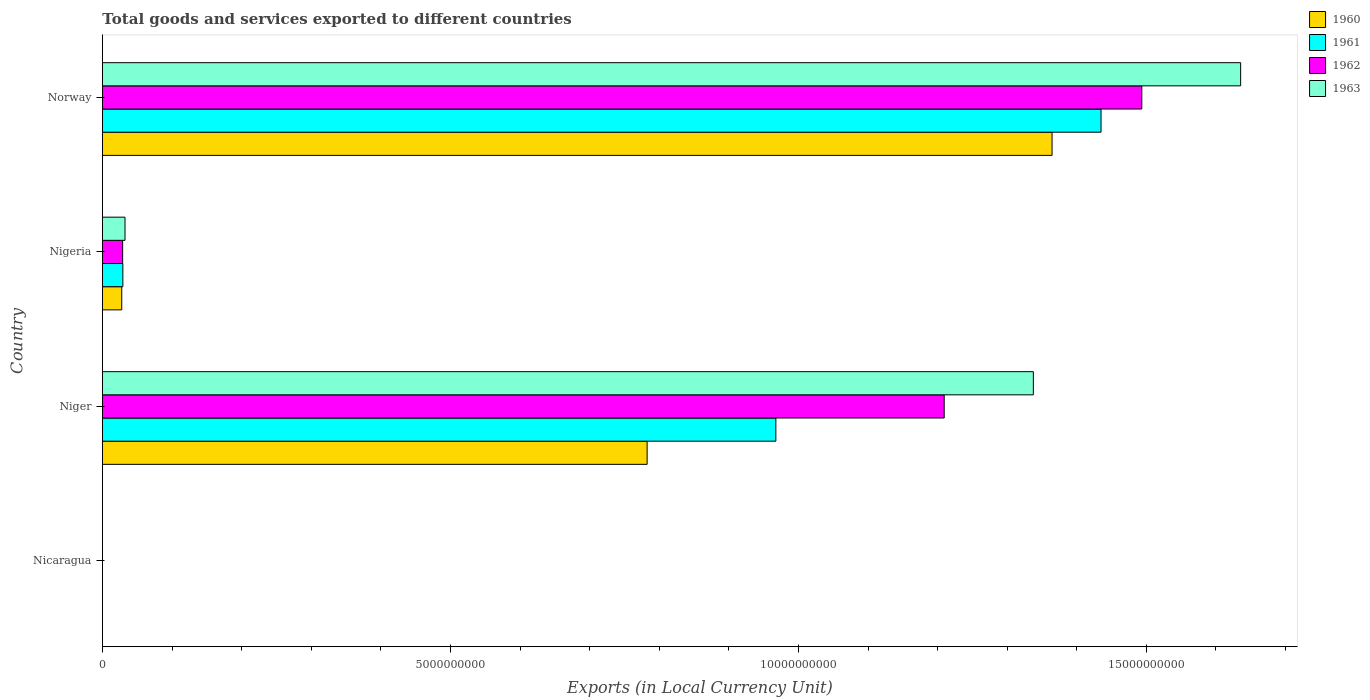How many different coloured bars are there?
Your response must be concise. 4. Are the number of bars per tick equal to the number of legend labels?
Your response must be concise. Yes. Are the number of bars on each tick of the Y-axis equal?
Ensure brevity in your answer.  Yes. How many bars are there on the 1st tick from the top?
Your answer should be very brief. 4. What is the label of the 3rd group of bars from the top?
Provide a short and direct response. Niger. In how many cases, is the number of bars for a given country not equal to the number of legend labels?
Offer a very short reply. 0. What is the Amount of goods and services exports in 1963 in Niger?
Provide a succinct answer. 1.34e+1. Across all countries, what is the maximum Amount of goods and services exports in 1960?
Your response must be concise. 1.36e+1. Across all countries, what is the minimum Amount of goods and services exports in 1961?
Make the answer very short. 0.12. In which country was the Amount of goods and services exports in 1962 maximum?
Your answer should be very brief. Norway. In which country was the Amount of goods and services exports in 1960 minimum?
Your response must be concise. Nicaragua. What is the total Amount of goods and services exports in 1962 in the graph?
Your answer should be compact. 2.73e+1. What is the difference between the Amount of goods and services exports in 1961 in Nicaragua and that in Niger?
Your answer should be compact. -9.68e+09. What is the difference between the Amount of goods and services exports in 1960 in Nicaragua and the Amount of goods and services exports in 1961 in Norway?
Offer a very short reply. -1.43e+1. What is the average Amount of goods and services exports in 1963 per country?
Your answer should be very brief. 7.51e+09. What is the difference between the Amount of goods and services exports in 1961 and Amount of goods and services exports in 1963 in Nicaragua?
Your answer should be compact. -0.06. What is the ratio of the Amount of goods and services exports in 1960 in Niger to that in Nigeria?
Ensure brevity in your answer.  28.25. What is the difference between the highest and the second highest Amount of goods and services exports in 1962?
Keep it short and to the point. 2.84e+09. What is the difference between the highest and the lowest Amount of goods and services exports in 1962?
Your answer should be very brief. 1.49e+1. Is it the case that in every country, the sum of the Amount of goods and services exports in 1961 and Amount of goods and services exports in 1960 is greater than the sum of Amount of goods and services exports in 1963 and Amount of goods and services exports in 1962?
Offer a terse response. No. Is it the case that in every country, the sum of the Amount of goods and services exports in 1962 and Amount of goods and services exports in 1961 is greater than the Amount of goods and services exports in 1963?
Your answer should be very brief. Yes. How many bars are there?
Your response must be concise. 16. Are the values on the major ticks of X-axis written in scientific E-notation?
Your response must be concise. No. How are the legend labels stacked?
Make the answer very short. Vertical. What is the title of the graph?
Ensure brevity in your answer.  Total goods and services exported to different countries. What is the label or title of the X-axis?
Offer a terse response. Exports (in Local Currency Unit). What is the Exports (in Local Currency Unit) in 1960 in Nicaragua?
Make the answer very short. 0.11. What is the Exports (in Local Currency Unit) of 1961 in Nicaragua?
Your answer should be compact. 0.12. What is the Exports (in Local Currency Unit) of 1962 in Nicaragua?
Your response must be concise. 0.15. What is the Exports (in Local Currency Unit) in 1963 in Nicaragua?
Provide a succinct answer. 0.18. What is the Exports (in Local Currency Unit) in 1960 in Niger?
Provide a short and direct response. 7.83e+09. What is the Exports (in Local Currency Unit) of 1961 in Niger?
Make the answer very short. 9.68e+09. What is the Exports (in Local Currency Unit) of 1962 in Niger?
Offer a very short reply. 1.21e+1. What is the Exports (in Local Currency Unit) of 1963 in Niger?
Make the answer very short. 1.34e+1. What is the Exports (in Local Currency Unit) of 1960 in Nigeria?
Keep it short and to the point. 2.77e+08. What is the Exports (in Local Currency Unit) of 1961 in Nigeria?
Offer a very short reply. 2.93e+08. What is the Exports (in Local Currency Unit) in 1962 in Nigeria?
Your response must be concise. 2.90e+08. What is the Exports (in Local Currency Unit) of 1963 in Nigeria?
Your answer should be very brief. 3.24e+08. What is the Exports (in Local Currency Unit) of 1960 in Norway?
Offer a very short reply. 1.36e+1. What is the Exports (in Local Currency Unit) of 1961 in Norway?
Keep it short and to the point. 1.43e+1. What is the Exports (in Local Currency Unit) in 1962 in Norway?
Give a very brief answer. 1.49e+1. What is the Exports (in Local Currency Unit) of 1963 in Norway?
Your answer should be compact. 1.64e+1. Across all countries, what is the maximum Exports (in Local Currency Unit) of 1960?
Offer a very short reply. 1.36e+1. Across all countries, what is the maximum Exports (in Local Currency Unit) in 1961?
Your answer should be compact. 1.43e+1. Across all countries, what is the maximum Exports (in Local Currency Unit) in 1962?
Make the answer very short. 1.49e+1. Across all countries, what is the maximum Exports (in Local Currency Unit) of 1963?
Your answer should be very brief. 1.64e+1. Across all countries, what is the minimum Exports (in Local Currency Unit) of 1960?
Make the answer very short. 0.11. Across all countries, what is the minimum Exports (in Local Currency Unit) in 1961?
Offer a very short reply. 0.12. Across all countries, what is the minimum Exports (in Local Currency Unit) in 1962?
Your response must be concise. 0.15. Across all countries, what is the minimum Exports (in Local Currency Unit) in 1963?
Your answer should be compact. 0.18. What is the total Exports (in Local Currency Unit) of 1960 in the graph?
Your answer should be compact. 2.17e+1. What is the total Exports (in Local Currency Unit) in 1961 in the graph?
Keep it short and to the point. 2.43e+1. What is the total Exports (in Local Currency Unit) of 1962 in the graph?
Give a very brief answer. 2.73e+1. What is the total Exports (in Local Currency Unit) in 1963 in the graph?
Ensure brevity in your answer.  3.01e+1. What is the difference between the Exports (in Local Currency Unit) in 1960 in Nicaragua and that in Niger?
Offer a terse response. -7.83e+09. What is the difference between the Exports (in Local Currency Unit) in 1961 in Nicaragua and that in Niger?
Your response must be concise. -9.68e+09. What is the difference between the Exports (in Local Currency Unit) of 1962 in Nicaragua and that in Niger?
Offer a very short reply. -1.21e+1. What is the difference between the Exports (in Local Currency Unit) of 1963 in Nicaragua and that in Niger?
Provide a succinct answer. -1.34e+1. What is the difference between the Exports (in Local Currency Unit) of 1960 in Nicaragua and that in Nigeria?
Your answer should be compact. -2.77e+08. What is the difference between the Exports (in Local Currency Unit) of 1961 in Nicaragua and that in Nigeria?
Offer a very short reply. -2.93e+08. What is the difference between the Exports (in Local Currency Unit) in 1962 in Nicaragua and that in Nigeria?
Give a very brief answer. -2.90e+08. What is the difference between the Exports (in Local Currency Unit) in 1963 in Nicaragua and that in Nigeria?
Make the answer very short. -3.24e+08. What is the difference between the Exports (in Local Currency Unit) of 1960 in Nicaragua and that in Norway?
Provide a succinct answer. -1.36e+1. What is the difference between the Exports (in Local Currency Unit) in 1961 in Nicaragua and that in Norway?
Give a very brief answer. -1.43e+1. What is the difference between the Exports (in Local Currency Unit) of 1962 in Nicaragua and that in Norway?
Ensure brevity in your answer.  -1.49e+1. What is the difference between the Exports (in Local Currency Unit) of 1963 in Nicaragua and that in Norway?
Offer a very short reply. -1.64e+1. What is the difference between the Exports (in Local Currency Unit) in 1960 in Niger and that in Nigeria?
Your answer should be very brief. 7.55e+09. What is the difference between the Exports (in Local Currency Unit) in 1961 in Niger and that in Nigeria?
Your response must be concise. 9.38e+09. What is the difference between the Exports (in Local Currency Unit) in 1962 in Niger and that in Nigeria?
Provide a succinct answer. 1.18e+1. What is the difference between the Exports (in Local Currency Unit) in 1963 in Niger and that in Nigeria?
Keep it short and to the point. 1.31e+1. What is the difference between the Exports (in Local Currency Unit) in 1960 in Niger and that in Norway?
Offer a very short reply. -5.82e+09. What is the difference between the Exports (in Local Currency Unit) in 1961 in Niger and that in Norway?
Keep it short and to the point. -4.67e+09. What is the difference between the Exports (in Local Currency Unit) in 1962 in Niger and that in Norway?
Your response must be concise. -2.84e+09. What is the difference between the Exports (in Local Currency Unit) in 1963 in Niger and that in Norway?
Offer a terse response. -2.98e+09. What is the difference between the Exports (in Local Currency Unit) in 1960 in Nigeria and that in Norway?
Offer a very short reply. -1.34e+1. What is the difference between the Exports (in Local Currency Unit) of 1961 in Nigeria and that in Norway?
Ensure brevity in your answer.  -1.41e+1. What is the difference between the Exports (in Local Currency Unit) of 1962 in Nigeria and that in Norway?
Your answer should be very brief. -1.46e+1. What is the difference between the Exports (in Local Currency Unit) in 1963 in Nigeria and that in Norway?
Provide a succinct answer. -1.60e+1. What is the difference between the Exports (in Local Currency Unit) in 1960 in Nicaragua and the Exports (in Local Currency Unit) in 1961 in Niger?
Ensure brevity in your answer.  -9.68e+09. What is the difference between the Exports (in Local Currency Unit) in 1960 in Nicaragua and the Exports (in Local Currency Unit) in 1962 in Niger?
Offer a very short reply. -1.21e+1. What is the difference between the Exports (in Local Currency Unit) of 1960 in Nicaragua and the Exports (in Local Currency Unit) of 1963 in Niger?
Provide a short and direct response. -1.34e+1. What is the difference between the Exports (in Local Currency Unit) of 1961 in Nicaragua and the Exports (in Local Currency Unit) of 1962 in Niger?
Your answer should be compact. -1.21e+1. What is the difference between the Exports (in Local Currency Unit) in 1961 in Nicaragua and the Exports (in Local Currency Unit) in 1963 in Niger?
Offer a very short reply. -1.34e+1. What is the difference between the Exports (in Local Currency Unit) of 1962 in Nicaragua and the Exports (in Local Currency Unit) of 1963 in Niger?
Offer a terse response. -1.34e+1. What is the difference between the Exports (in Local Currency Unit) of 1960 in Nicaragua and the Exports (in Local Currency Unit) of 1961 in Nigeria?
Ensure brevity in your answer.  -2.93e+08. What is the difference between the Exports (in Local Currency Unit) in 1960 in Nicaragua and the Exports (in Local Currency Unit) in 1962 in Nigeria?
Offer a terse response. -2.90e+08. What is the difference between the Exports (in Local Currency Unit) of 1960 in Nicaragua and the Exports (in Local Currency Unit) of 1963 in Nigeria?
Make the answer very short. -3.24e+08. What is the difference between the Exports (in Local Currency Unit) in 1961 in Nicaragua and the Exports (in Local Currency Unit) in 1962 in Nigeria?
Give a very brief answer. -2.90e+08. What is the difference between the Exports (in Local Currency Unit) in 1961 in Nicaragua and the Exports (in Local Currency Unit) in 1963 in Nigeria?
Offer a terse response. -3.24e+08. What is the difference between the Exports (in Local Currency Unit) in 1962 in Nicaragua and the Exports (in Local Currency Unit) in 1963 in Nigeria?
Provide a short and direct response. -3.24e+08. What is the difference between the Exports (in Local Currency Unit) of 1960 in Nicaragua and the Exports (in Local Currency Unit) of 1961 in Norway?
Your answer should be very brief. -1.43e+1. What is the difference between the Exports (in Local Currency Unit) of 1960 in Nicaragua and the Exports (in Local Currency Unit) of 1962 in Norway?
Your answer should be very brief. -1.49e+1. What is the difference between the Exports (in Local Currency Unit) in 1960 in Nicaragua and the Exports (in Local Currency Unit) in 1963 in Norway?
Keep it short and to the point. -1.64e+1. What is the difference between the Exports (in Local Currency Unit) of 1961 in Nicaragua and the Exports (in Local Currency Unit) of 1962 in Norway?
Offer a very short reply. -1.49e+1. What is the difference between the Exports (in Local Currency Unit) in 1961 in Nicaragua and the Exports (in Local Currency Unit) in 1963 in Norway?
Your answer should be compact. -1.64e+1. What is the difference between the Exports (in Local Currency Unit) of 1962 in Nicaragua and the Exports (in Local Currency Unit) of 1963 in Norway?
Keep it short and to the point. -1.64e+1. What is the difference between the Exports (in Local Currency Unit) of 1960 in Niger and the Exports (in Local Currency Unit) of 1961 in Nigeria?
Keep it short and to the point. 7.53e+09. What is the difference between the Exports (in Local Currency Unit) of 1960 in Niger and the Exports (in Local Currency Unit) of 1962 in Nigeria?
Provide a short and direct response. 7.54e+09. What is the difference between the Exports (in Local Currency Unit) of 1960 in Niger and the Exports (in Local Currency Unit) of 1963 in Nigeria?
Keep it short and to the point. 7.50e+09. What is the difference between the Exports (in Local Currency Unit) of 1961 in Niger and the Exports (in Local Currency Unit) of 1962 in Nigeria?
Ensure brevity in your answer.  9.39e+09. What is the difference between the Exports (in Local Currency Unit) in 1961 in Niger and the Exports (in Local Currency Unit) in 1963 in Nigeria?
Give a very brief answer. 9.35e+09. What is the difference between the Exports (in Local Currency Unit) of 1962 in Niger and the Exports (in Local Currency Unit) of 1963 in Nigeria?
Ensure brevity in your answer.  1.18e+1. What is the difference between the Exports (in Local Currency Unit) in 1960 in Niger and the Exports (in Local Currency Unit) in 1961 in Norway?
Your answer should be very brief. -6.52e+09. What is the difference between the Exports (in Local Currency Unit) of 1960 in Niger and the Exports (in Local Currency Unit) of 1962 in Norway?
Give a very brief answer. -7.11e+09. What is the difference between the Exports (in Local Currency Unit) of 1960 in Niger and the Exports (in Local Currency Unit) of 1963 in Norway?
Your answer should be compact. -8.53e+09. What is the difference between the Exports (in Local Currency Unit) in 1961 in Niger and the Exports (in Local Currency Unit) in 1962 in Norway?
Provide a succinct answer. -5.26e+09. What is the difference between the Exports (in Local Currency Unit) in 1961 in Niger and the Exports (in Local Currency Unit) in 1963 in Norway?
Make the answer very short. -6.68e+09. What is the difference between the Exports (in Local Currency Unit) of 1962 in Niger and the Exports (in Local Currency Unit) of 1963 in Norway?
Provide a succinct answer. -4.26e+09. What is the difference between the Exports (in Local Currency Unit) of 1960 in Nigeria and the Exports (in Local Currency Unit) of 1961 in Norway?
Your response must be concise. -1.41e+1. What is the difference between the Exports (in Local Currency Unit) of 1960 in Nigeria and the Exports (in Local Currency Unit) of 1962 in Norway?
Offer a terse response. -1.47e+1. What is the difference between the Exports (in Local Currency Unit) of 1960 in Nigeria and the Exports (in Local Currency Unit) of 1963 in Norway?
Your response must be concise. -1.61e+1. What is the difference between the Exports (in Local Currency Unit) of 1961 in Nigeria and the Exports (in Local Currency Unit) of 1962 in Norway?
Make the answer very short. -1.46e+1. What is the difference between the Exports (in Local Currency Unit) in 1961 in Nigeria and the Exports (in Local Currency Unit) in 1963 in Norway?
Your response must be concise. -1.61e+1. What is the difference between the Exports (in Local Currency Unit) in 1962 in Nigeria and the Exports (in Local Currency Unit) in 1963 in Norway?
Give a very brief answer. -1.61e+1. What is the average Exports (in Local Currency Unit) in 1960 per country?
Ensure brevity in your answer.  5.44e+09. What is the average Exports (in Local Currency Unit) in 1961 per country?
Offer a very short reply. 6.08e+09. What is the average Exports (in Local Currency Unit) of 1962 per country?
Provide a succinct answer. 6.83e+09. What is the average Exports (in Local Currency Unit) of 1963 per country?
Provide a succinct answer. 7.51e+09. What is the difference between the Exports (in Local Currency Unit) in 1960 and Exports (in Local Currency Unit) in 1961 in Nicaragua?
Your response must be concise. -0.01. What is the difference between the Exports (in Local Currency Unit) in 1960 and Exports (in Local Currency Unit) in 1962 in Nicaragua?
Offer a terse response. -0.04. What is the difference between the Exports (in Local Currency Unit) in 1960 and Exports (in Local Currency Unit) in 1963 in Nicaragua?
Keep it short and to the point. -0.07. What is the difference between the Exports (in Local Currency Unit) of 1961 and Exports (in Local Currency Unit) of 1962 in Nicaragua?
Make the answer very short. -0.03. What is the difference between the Exports (in Local Currency Unit) of 1961 and Exports (in Local Currency Unit) of 1963 in Nicaragua?
Offer a very short reply. -0.06. What is the difference between the Exports (in Local Currency Unit) in 1962 and Exports (in Local Currency Unit) in 1963 in Nicaragua?
Provide a succinct answer. -0.03. What is the difference between the Exports (in Local Currency Unit) in 1960 and Exports (in Local Currency Unit) in 1961 in Niger?
Your answer should be very brief. -1.85e+09. What is the difference between the Exports (in Local Currency Unit) in 1960 and Exports (in Local Currency Unit) in 1962 in Niger?
Ensure brevity in your answer.  -4.27e+09. What is the difference between the Exports (in Local Currency Unit) in 1960 and Exports (in Local Currency Unit) in 1963 in Niger?
Give a very brief answer. -5.55e+09. What is the difference between the Exports (in Local Currency Unit) in 1961 and Exports (in Local Currency Unit) in 1962 in Niger?
Give a very brief answer. -2.42e+09. What is the difference between the Exports (in Local Currency Unit) of 1961 and Exports (in Local Currency Unit) of 1963 in Niger?
Offer a very short reply. -3.70e+09. What is the difference between the Exports (in Local Currency Unit) in 1962 and Exports (in Local Currency Unit) in 1963 in Niger?
Your response must be concise. -1.28e+09. What is the difference between the Exports (in Local Currency Unit) in 1960 and Exports (in Local Currency Unit) in 1961 in Nigeria?
Make the answer very short. -1.61e+07. What is the difference between the Exports (in Local Currency Unit) of 1960 and Exports (in Local Currency Unit) of 1962 in Nigeria?
Provide a short and direct response. -1.30e+07. What is the difference between the Exports (in Local Currency Unit) of 1960 and Exports (in Local Currency Unit) of 1963 in Nigeria?
Provide a succinct answer. -4.69e+07. What is the difference between the Exports (in Local Currency Unit) in 1961 and Exports (in Local Currency Unit) in 1962 in Nigeria?
Your response must be concise. 3.12e+06. What is the difference between the Exports (in Local Currency Unit) of 1961 and Exports (in Local Currency Unit) of 1963 in Nigeria?
Provide a short and direct response. -3.08e+07. What is the difference between the Exports (in Local Currency Unit) of 1962 and Exports (in Local Currency Unit) of 1963 in Nigeria?
Give a very brief answer. -3.40e+07. What is the difference between the Exports (in Local Currency Unit) in 1960 and Exports (in Local Currency Unit) in 1961 in Norway?
Ensure brevity in your answer.  -7.04e+08. What is the difference between the Exports (in Local Currency Unit) in 1960 and Exports (in Local Currency Unit) in 1962 in Norway?
Provide a succinct answer. -1.29e+09. What is the difference between the Exports (in Local Currency Unit) in 1960 and Exports (in Local Currency Unit) in 1963 in Norway?
Keep it short and to the point. -2.71e+09. What is the difference between the Exports (in Local Currency Unit) in 1961 and Exports (in Local Currency Unit) in 1962 in Norway?
Keep it short and to the point. -5.86e+08. What is the difference between the Exports (in Local Currency Unit) of 1961 and Exports (in Local Currency Unit) of 1963 in Norway?
Provide a short and direct response. -2.01e+09. What is the difference between the Exports (in Local Currency Unit) of 1962 and Exports (in Local Currency Unit) of 1963 in Norway?
Ensure brevity in your answer.  -1.42e+09. What is the ratio of the Exports (in Local Currency Unit) of 1960 in Nicaragua to that in Niger?
Keep it short and to the point. 0. What is the ratio of the Exports (in Local Currency Unit) of 1961 in Nicaragua to that in Niger?
Provide a succinct answer. 0. What is the ratio of the Exports (in Local Currency Unit) of 1962 in Nicaragua to that in Niger?
Your response must be concise. 0. What is the ratio of the Exports (in Local Currency Unit) in 1963 in Nicaragua to that in Nigeria?
Provide a succinct answer. 0. What is the ratio of the Exports (in Local Currency Unit) in 1960 in Nicaragua to that in Norway?
Offer a terse response. 0. What is the ratio of the Exports (in Local Currency Unit) of 1961 in Nicaragua to that in Norway?
Give a very brief answer. 0. What is the ratio of the Exports (in Local Currency Unit) in 1962 in Nicaragua to that in Norway?
Make the answer very short. 0. What is the ratio of the Exports (in Local Currency Unit) of 1960 in Niger to that in Nigeria?
Offer a very short reply. 28.25. What is the ratio of the Exports (in Local Currency Unit) in 1961 in Niger to that in Nigeria?
Make the answer very short. 33.01. What is the ratio of the Exports (in Local Currency Unit) of 1962 in Niger to that in Nigeria?
Offer a very short reply. 41.71. What is the ratio of the Exports (in Local Currency Unit) of 1963 in Niger to that in Nigeria?
Your answer should be very brief. 41.29. What is the ratio of the Exports (in Local Currency Unit) in 1960 in Niger to that in Norway?
Give a very brief answer. 0.57. What is the ratio of the Exports (in Local Currency Unit) in 1961 in Niger to that in Norway?
Ensure brevity in your answer.  0.67. What is the ratio of the Exports (in Local Currency Unit) of 1962 in Niger to that in Norway?
Your answer should be very brief. 0.81. What is the ratio of the Exports (in Local Currency Unit) in 1963 in Niger to that in Norway?
Keep it short and to the point. 0.82. What is the ratio of the Exports (in Local Currency Unit) of 1960 in Nigeria to that in Norway?
Keep it short and to the point. 0.02. What is the ratio of the Exports (in Local Currency Unit) of 1961 in Nigeria to that in Norway?
Your answer should be compact. 0.02. What is the ratio of the Exports (in Local Currency Unit) of 1962 in Nigeria to that in Norway?
Provide a succinct answer. 0.02. What is the ratio of the Exports (in Local Currency Unit) of 1963 in Nigeria to that in Norway?
Make the answer very short. 0.02. What is the difference between the highest and the second highest Exports (in Local Currency Unit) of 1960?
Provide a short and direct response. 5.82e+09. What is the difference between the highest and the second highest Exports (in Local Currency Unit) of 1961?
Your answer should be very brief. 4.67e+09. What is the difference between the highest and the second highest Exports (in Local Currency Unit) of 1962?
Provide a short and direct response. 2.84e+09. What is the difference between the highest and the second highest Exports (in Local Currency Unit) in 1963?
Your answer should be compact. 2.98e+09. What is the difference between the highest and the lowest Exports (in Local Currency Unit) of 1960?
Your answer should be compact. 1.36e+1. What is the difference between the highest and the lowest Exports (in Local Currency Unit) in 1961?
Make the answer very short. 1.43e+1. What is the difference between the highest and the lowest Exports (in Local Currency Unit) in 1962?
Your answer should be compact. 1.49e+1. What is the difference between the highest and the lowest Exports (in Local Currency Unit) of 1963?
Keep it short and to the point. 1.64e+1. 